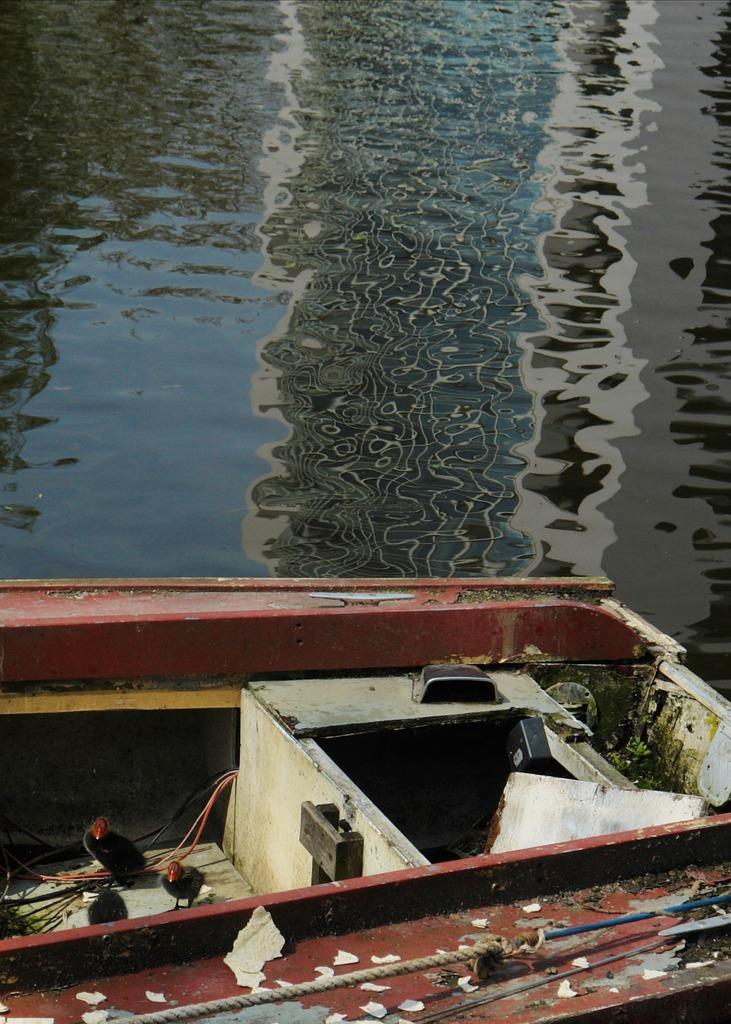What is the main subject in the foreground of the image? There is a boat in the foreground of the image. Where is the boat located? The boat is in the water. Can you describe the time of day when the image was taken? The image is likely taken during the day, as there is sufficient light to see the boat and water clearly. What type of body of water is depicted in the image? The location appears to be a lake. How many passengers are on the boat, and what color are their wings? There is no information about passengers or wings in the image, as it only features a boat in the water. 